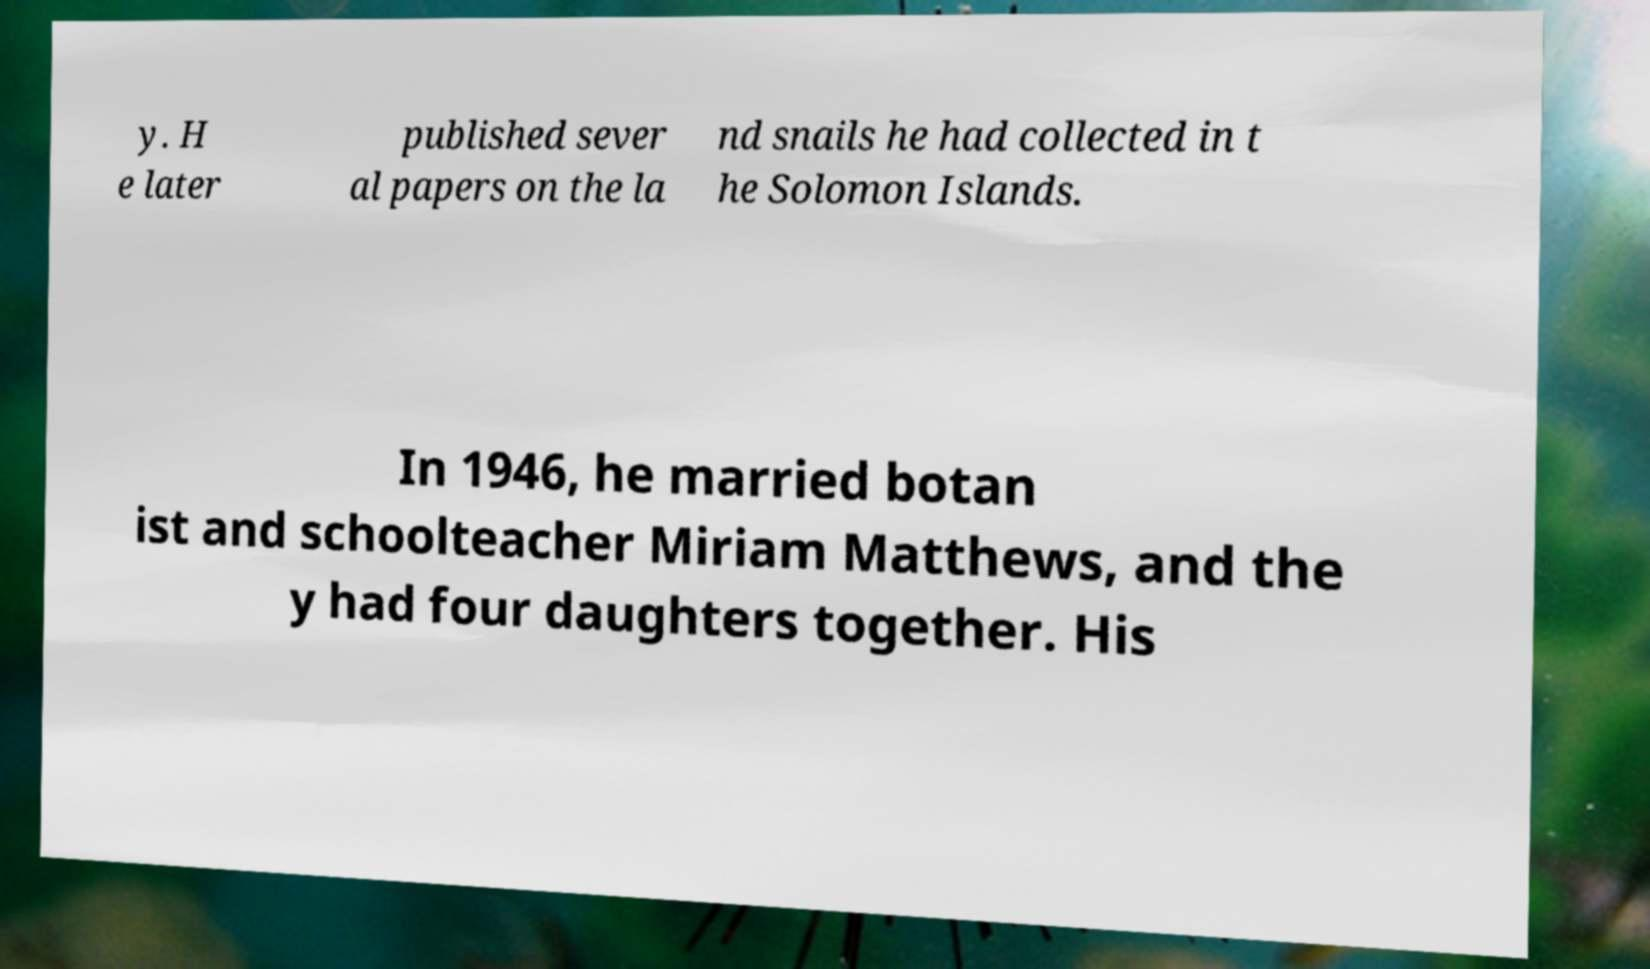Can you read and provide the text displayed in the image?This photo seems to have some interesting text. Can you extract and type it out for me? y. H e later published sever al papers on the la nd snails he had collected in t he Solomon Islands. In 1946, he married botan ist and schoolteacher Miriam Matthews, and the y had four daughters together. His 